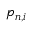<formula> <loc_0><loc_0><loc_500><loc_500>p _ { n , i }</formula> 